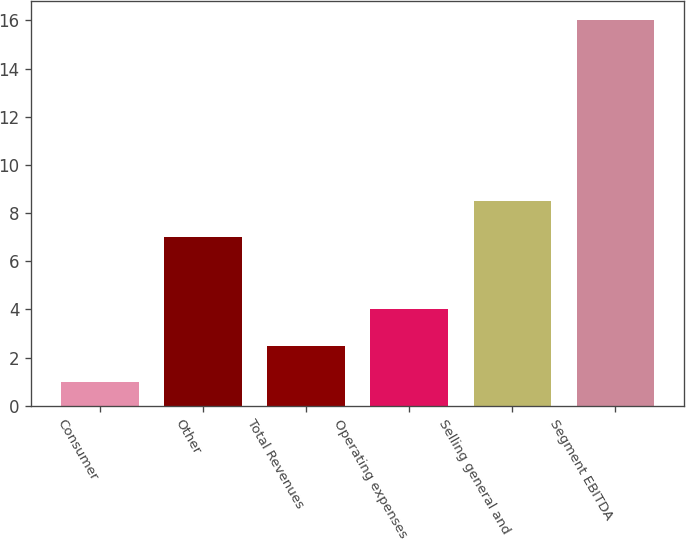<chart> <loc_0><loc_0><loc_500><loc_500><bar_chart><fcel>Consumer<fcel>Other<fcel>Total Revenues<fcel>Operating expenses<fcel>Selling general and<fcel>Segment EBITDA<nl><fcel>1<fcel>7<fcel>2.5<fcel>4<fcel>8.5<fcel>16<nl></chart> 